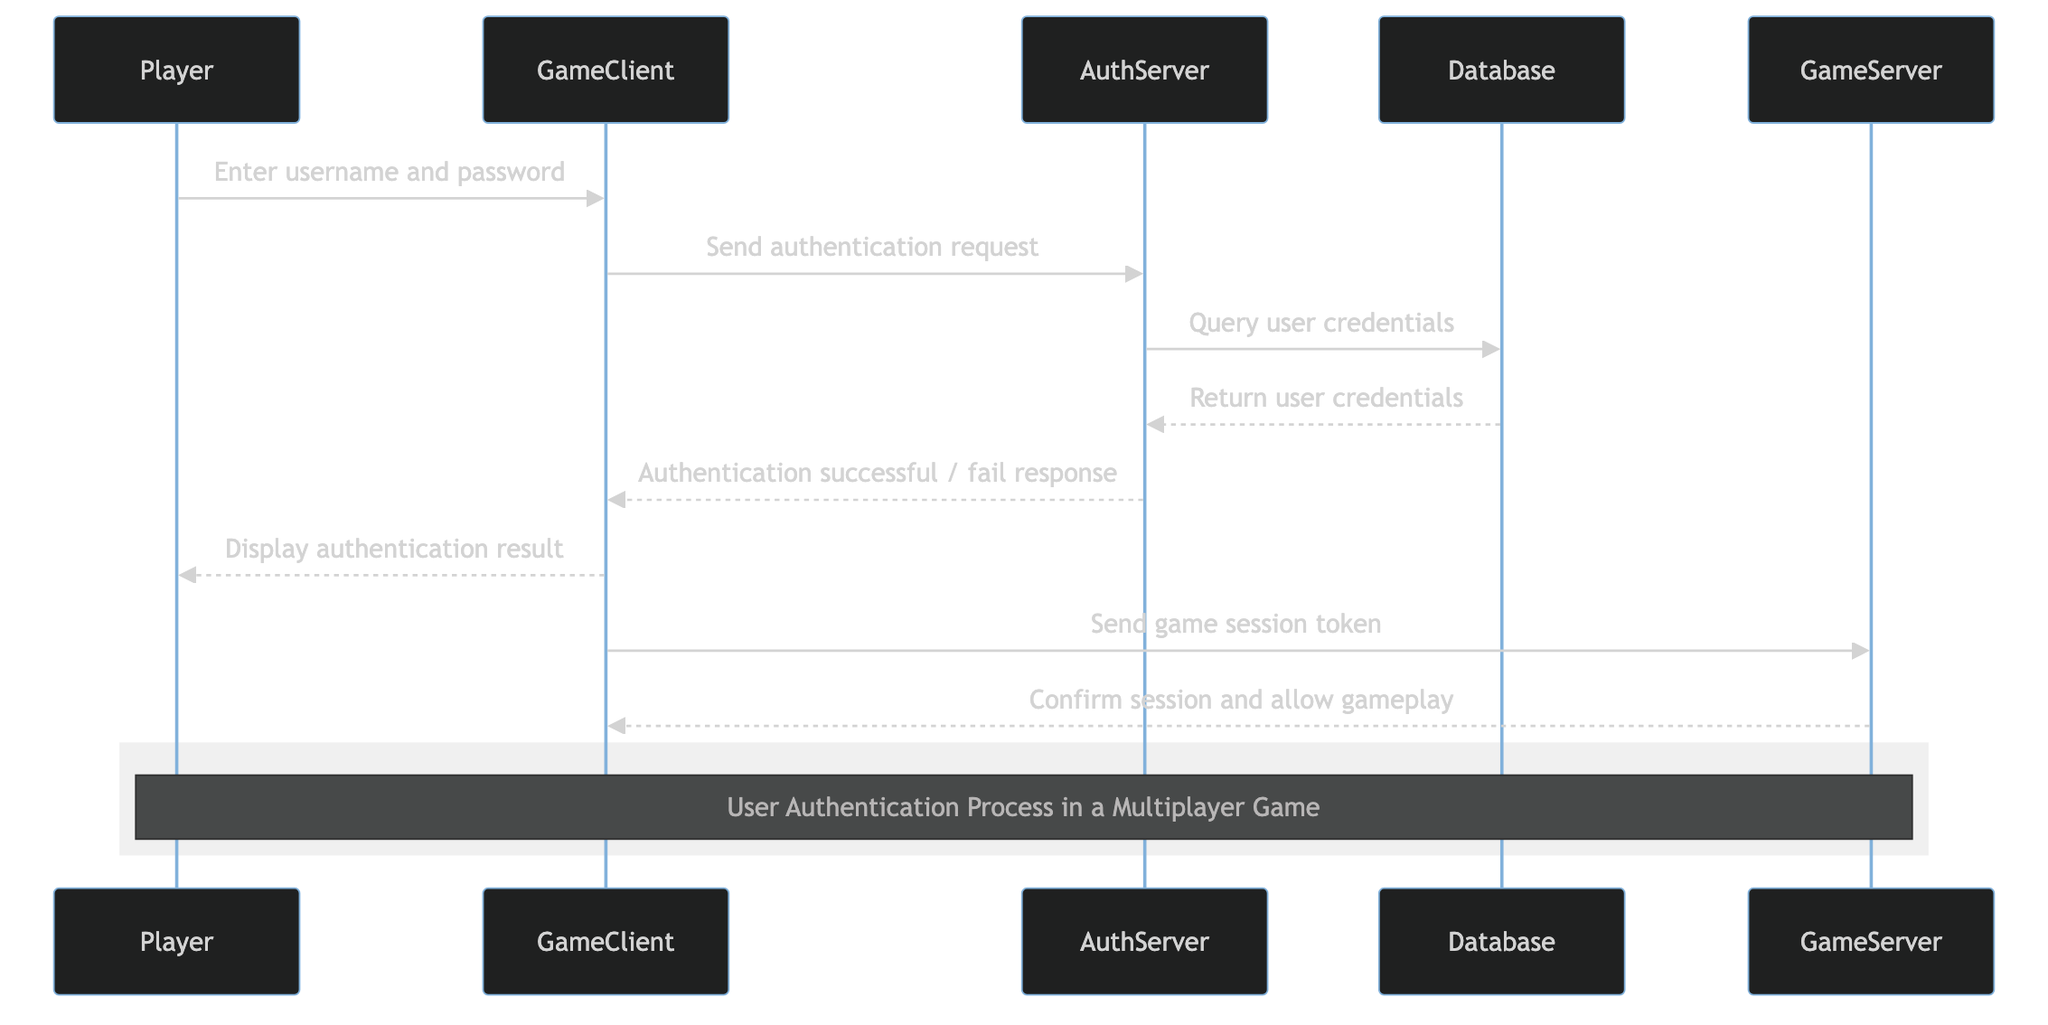What is the first action in the diagram? The first action is initiated by the Player who enters their username and password. This is shown at the start of the sequence diagram, where the Player sends a message to the GameClient.
Answer: Enter username and password How many participants are in the diagram? The diagram contains five participants: Player, GameClient, AuthServer, Database, and GameServer. This can be counted by observing the distinct roles that are included in the actors section of the diagram.
Answer: Five Which participant handles the authentication requests? The AuthServer is responsible for handling the authentication requests, as indicated in the role descriptions.
Answer: AuthServer What does the GameClient send to the AuthServer? The GameClient sends an authentication request to the AuthServer after receiving the user's input. This is clearly shown as a direct message in the flow of the diagram.
Answer: Send authentication request What is the final action taken by the GameServer? The final action taken by the GameServer is to confirm the session and allow gameplay. This is the last message shown coming from the GameServer returning to the GameClient.
Answer: Confirm session and allow gameplay What is returned from the Database to the AuthServer? The Database returns user credentials to the AuthServer as part of the authentication process. This message flow is depicted after the query is sent from the AuthServer.
Answer: Return user credentials What happens if the authentication is successful? If the authentication is successful, the AuthServer sends an "Authentication successful" response back to the GameClient, which then displays the result to the Player. This flow shows how successful authentication leads to subsequent actions.
Answer: Authentication successful What type of information is displayed to the Player? The authentication result, indicating whether the authentication was successful or failed, is displayed to the Player by the GameClient.
Answer: Display authentication result What message does the GameClient send to the GameServer after authentication? After authentication, the GameClient sends a game session token to the GameServer, which is an essential step for transitioning into gameplay.
Answer: Send game session token 